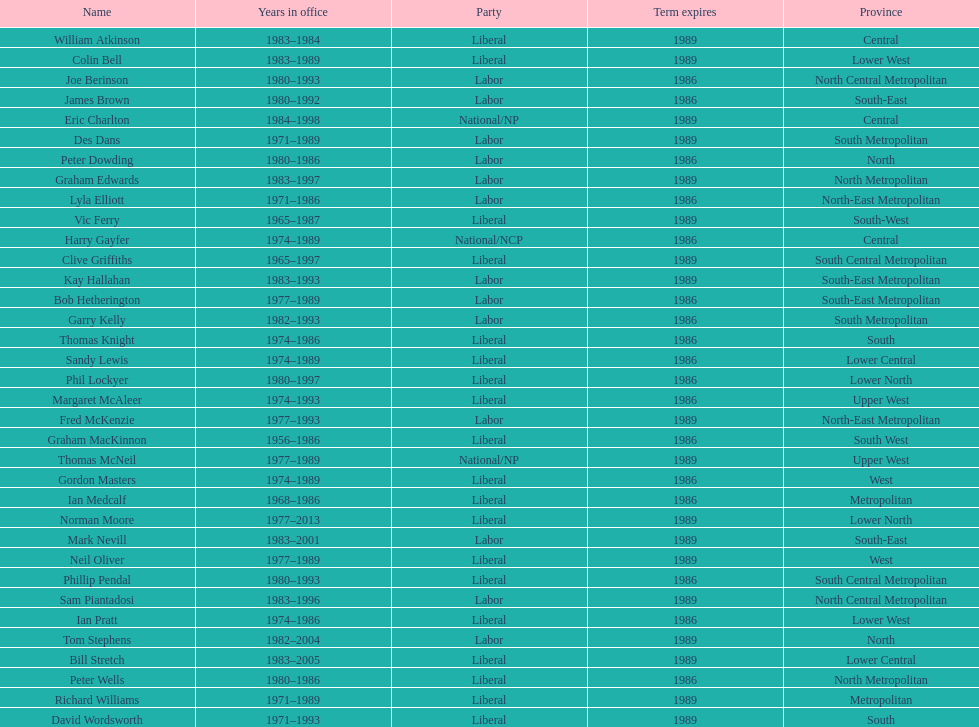What was phil lockyer's party? Liberal. 